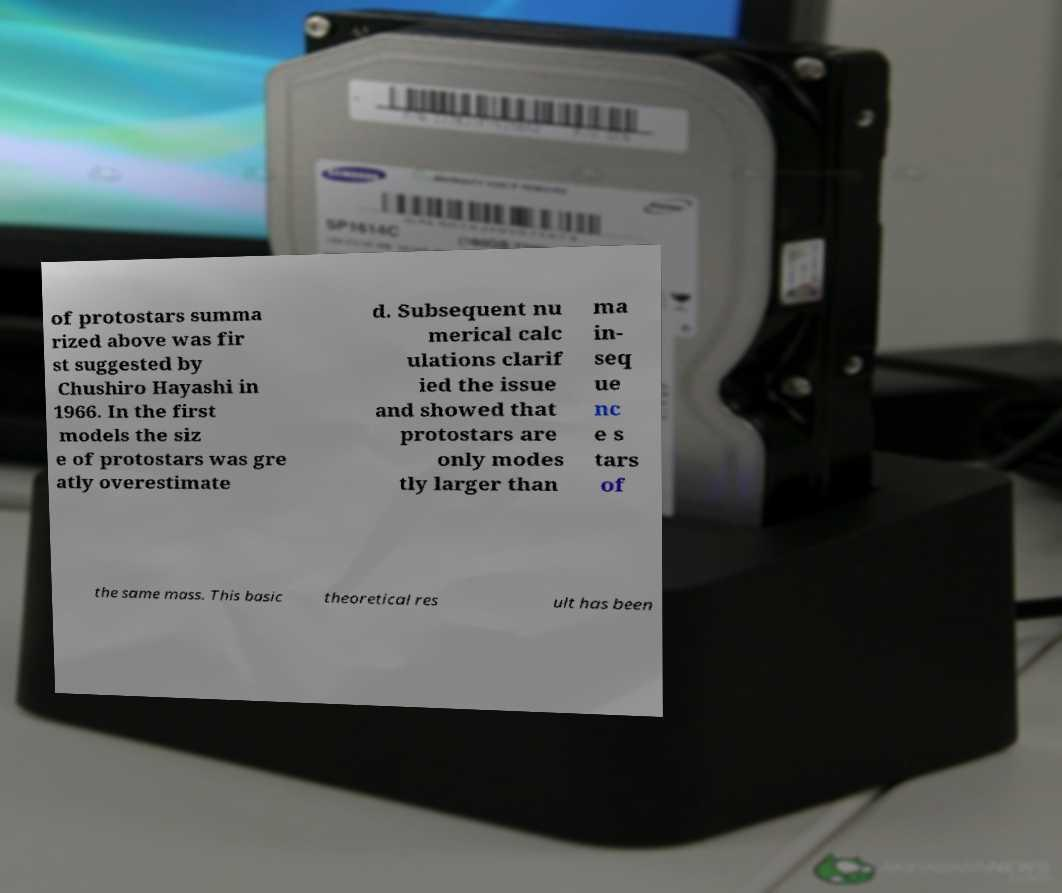For documentation purposes, I need the text within this image transcribed. Could you provide that? of protostars summa rized above was fir st suggested by Chushiro Hayashi in 1966. In the first models the siz e of protostars was gre atly overestimate d. Subsequent nu merical calc ulations clarif ied the issue and showed that protostars are only modes tly larger than ma in- seq ue nc e s tars of the same mass. This basic theoretical res ult has been 